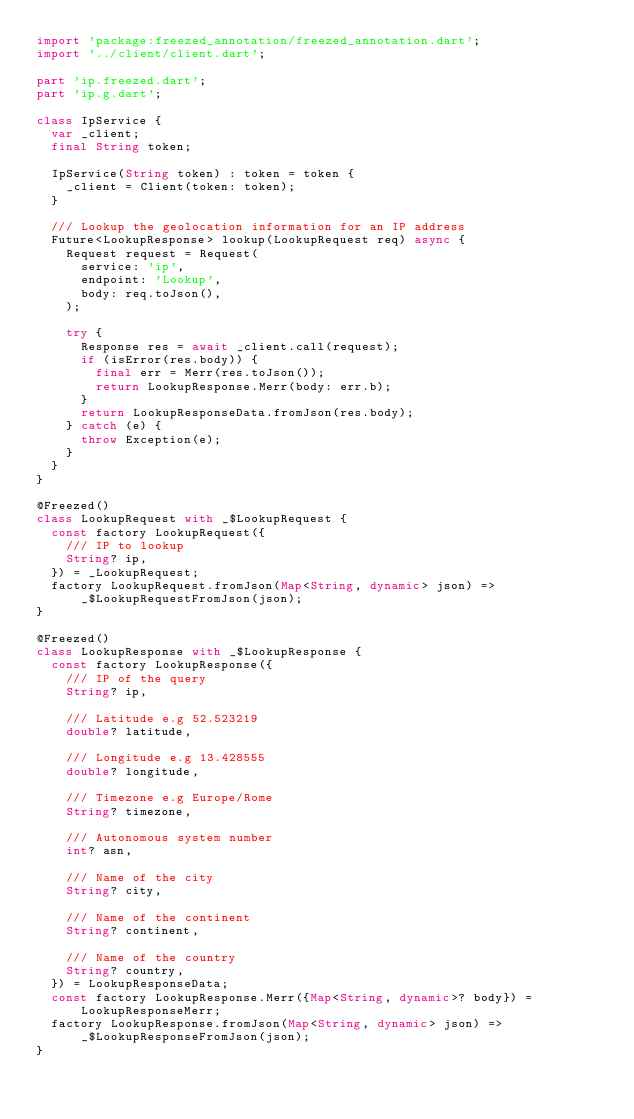Convert code to text. <code><loc_0><loc_0><loc_500><loc_500><_Dart_>import 'package:freezed_annotation/freezed_annotation.dart';
import '../client/client.dart';

part 'ip.freezed.dart';
part 'ip.g.dart';

class IpService {
  var _client;
  final String token;

  IpService(String token) : token = token {
    _client = Client(token: token);
  }

  /// Lookup the geolocation information for an IP address
  Future<LookupResponse> lookup(LookupRequest req) async {
    Request request = Request(
      service: 'ip',
      endpoint: 'Lookup',
      body: req.toJson(),
    );

    try {
      Response res = await _client.call(request);
      if (isError(res.body)) {
        final err = Merr(res.toJson());
        return LookupResponse.Merr(body: err.b);
      }
      return LookupResponseData.fromJson(res.body);
    } catch (e) {
      throw Exception(e);
    }
  }
}

@Freezed()
class LookupRequest with _$LookupRequest {
  const factory LookupRequest({
    /// IP to lookup
    String? ip,
  }) = _LookupRequest;
  factory LookupRequest.fromJson(Map<String, dynamic> json) =>
      _$LookupRequestFromJson(json);
}

@Freezed()
class LookupResponse with _$LookupResponse {
  const factory LookupResponse({
    /// IP of the query
    String? ip,

    /// Latitude e.g 52.523219
    double? latitude,

    /// Longitude e.g 13.428555
    double? longitude,

    /// Timezone e.g Europe/Rome
    String? timezone,

    /// Autonomous system number
    int? asn,

    /// Name of the city
    String? city,

    /// Name of the continent
    String? continent,

    /// Name of the country
    String? country,
  }) = LookupResponseData;
  const factory LookupResponse.Merr({Map<String, dynamic>? body}) =
      LookupResponseMerr;
  factory LookupResponse.fromJson(Map<String, dynamic> json) =>
      _$LookupResponseFromJson(json);
}
</code> 